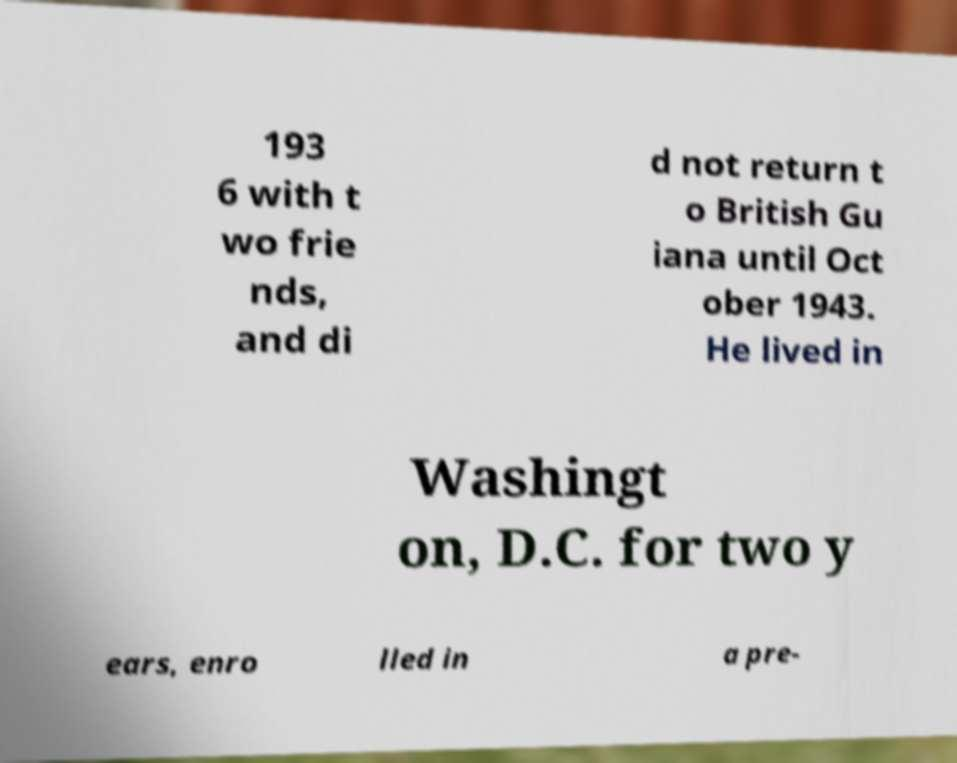Can you accurately transcribe the text from the provided image for me? 193 6 with t wo frie nds, and di d not return t o British Gu iana until Oct ober 1943. He lived in Washingt on, D.C. for two y ears, enro lled in a pre- 